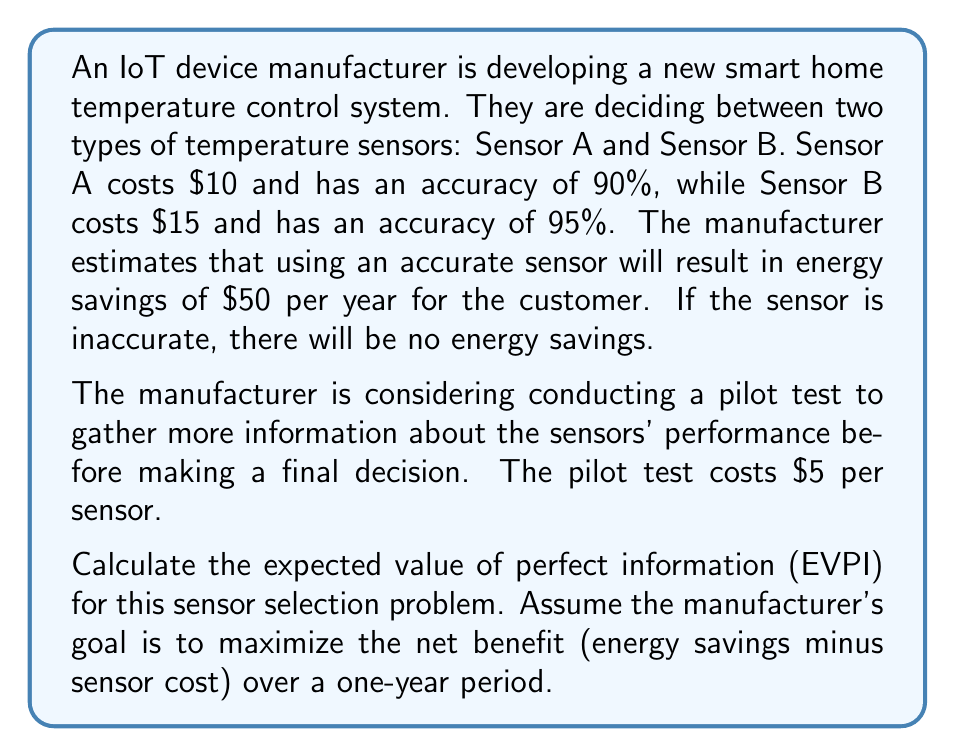Give your solution to this math problem. To solve this problem, we'll follow these steps:

1. Calculate the expected value (EV) of each sensor without additional information.
2. Determine the optimal decision based on current information.
3. Calculate the expected value with perfect information (EVPI).
4. Calculate the expected value of perfect information (EVPI).

Step 1: Calculate the EV of each sensor

For Sensor A:
$$ EV(A) = 0.90 \times ($50 - $10) + 0.10 \times (-$10) = $35 $$

For Sensor B:
$$ EV(B) = 0.95 \times ($50 - $15) + 0.05 \times (-$15) = $32.75 $$

Step 2: Determine the optimal decision

Based on the current information, Sensor A has a higher expected value, so it would be the optimal choice.

Step 3: Calculate the expected value with perfect information

With perfect information, we would always choose the correct sensor:
$$ EV_{perfect} = 1.00 \times ($50 - $10) = $40 $$

Step 4: Calculate the EVPI

The EVPI is the difference between the expected value with perfect information and the expected value of the best option without additional information:

$$ EVPI = EV_{perfect} - \max(EV(A), EV(B)) $$
$$ EVPI = $40 - $35 = $5 $$
Answer: The expected value of perfect information (EVPI) for this sensor selection problem is $5. 